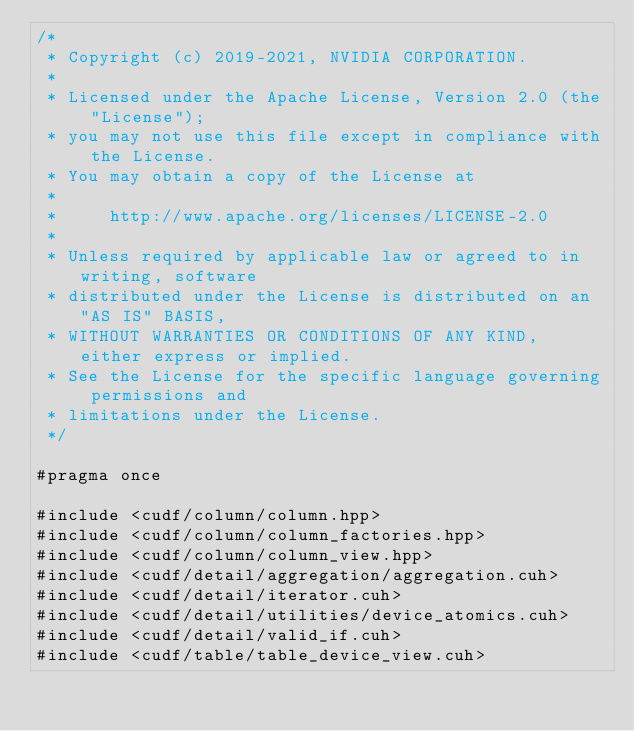<code> <loc_0><loc_0><loc_500><loc_500><_Cuda_>/*
 * Copyright (c) 2019-2021, NVIDIA CORPORATION.
 *
 * Licensed under the Apache License, Version 2.0 (the "License");
 * you may not use this file except in compliance with the License.
 * You may obtain a copy of the License at
 *
 *     http://www.apache.org/licenses/LICENSE-2.0
 *
 * Unless required by applicable law or agreed to in writing, software
 * distributed under the License is distributed on an "AS IS" BASIS,
 * WITHOUT WARRANTIES OR CONDITIONS OF ANY KIND, either express or implied.
 * See the License for the specific language governing permissions and
 * limitations under the License.
 */

#pragma once

#include <cudf/column/column.hpp>
#include <cudf/column/column_factories.hpp>
#include <cudf/column/column_view.hpp>
#include <cudf/detail/aggregation/aggregation.cuh>
#include <cudf/detail/iterator.cuh>
#include <cudf/detail/utilities/device_atomics.cuh>
#include <cudf/detail/valid_if.cuh>
#include <cudf/table/table_device_view.cuh></code> 